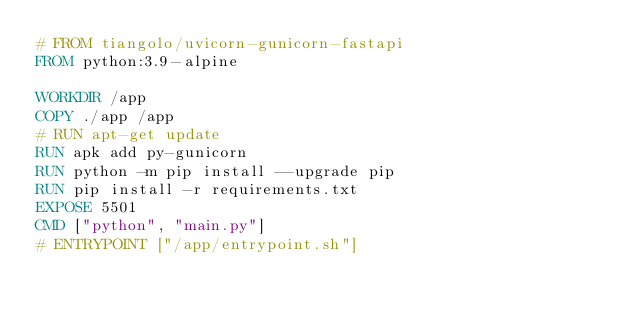Convert code to text. <code><loc_0><loc_0><loc_500><loc_500><_Dockerfile_># FROM tiangolo/uvicorn-gunicorn-fastapi
FROM python:3.9-alpine

WORKDIR /app
COPY ./app /app
# RUN apt-get update 
RUN apk add py-gunicorn
RUN python -m pip install --upgrade pip
RUN pip install -r requirements.txt
EXPOSE 5501
CMD ["python", "main.py"]
# ENTRYPOINT ["/app/entrypoint.sh"]
</code> 